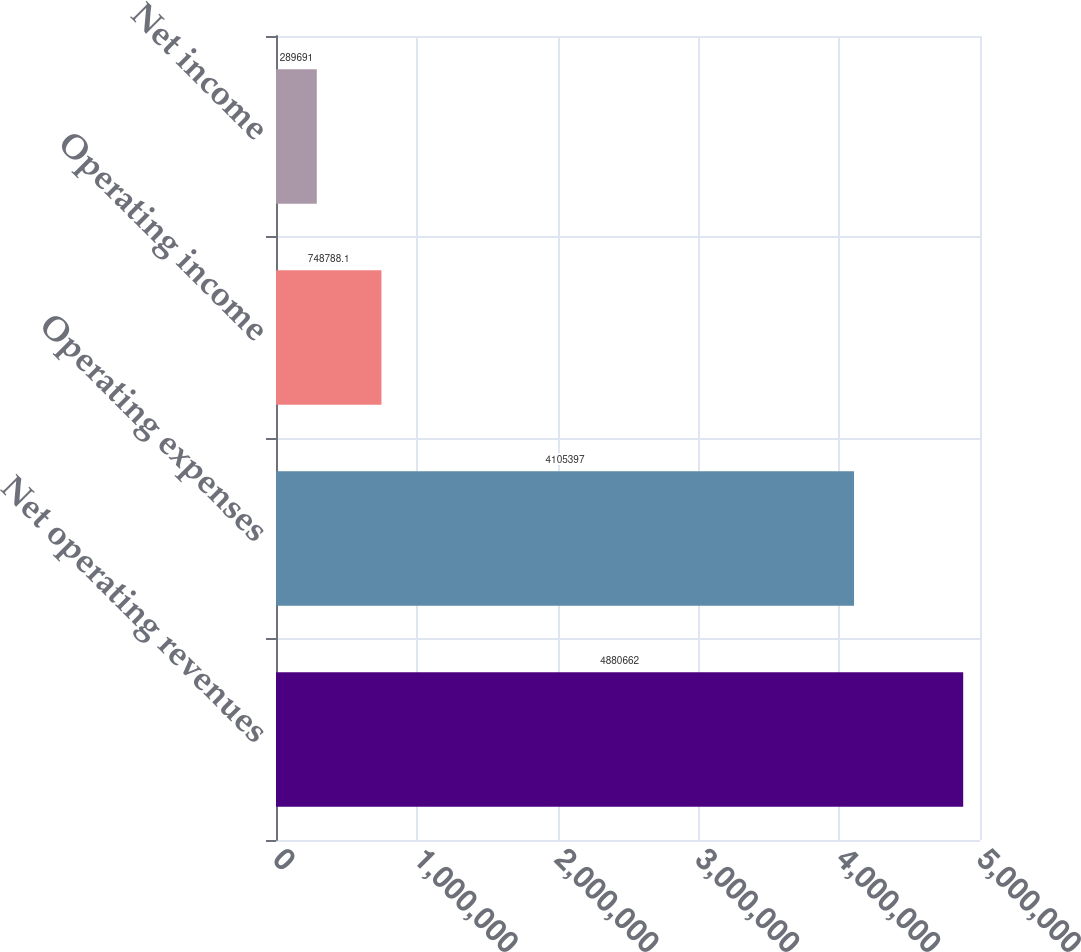Convert chart to OTSL. <chart><loc_0><loc_0><loc_500><loc_500><bar_chart><fcel>Net operating revenues<fcel>Operating expenses<fcel>Operating income<fcel>Net income<nl><fcel>4.88066e+06<fcel>4.1054e+06<fcel>748788<fcel>289691<nl></chart> 